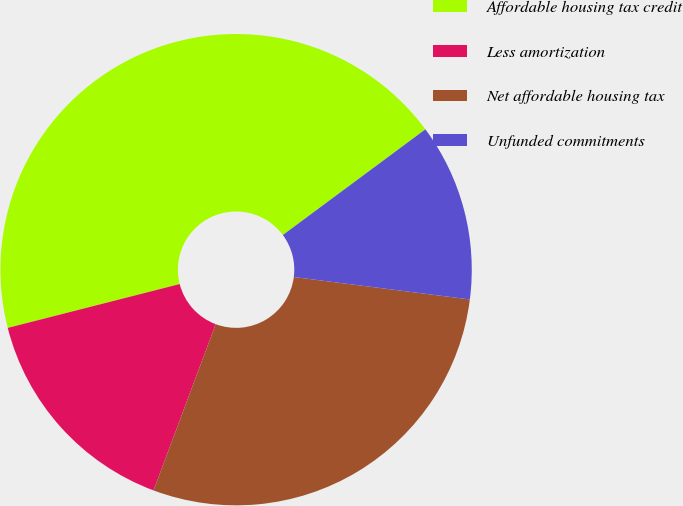<chart> <loc_0><loc_0><loc_500><loc_500><pie_chart><fcel>Affordable housing tax credit<fcel>Less amortization<fcel>Net affordable housing tax<fcel>Unfunded commitments<nl><fcel>43.82%<fcel>15.33%<fcel>28.68%<fcel>12.17%<nl></chart> 